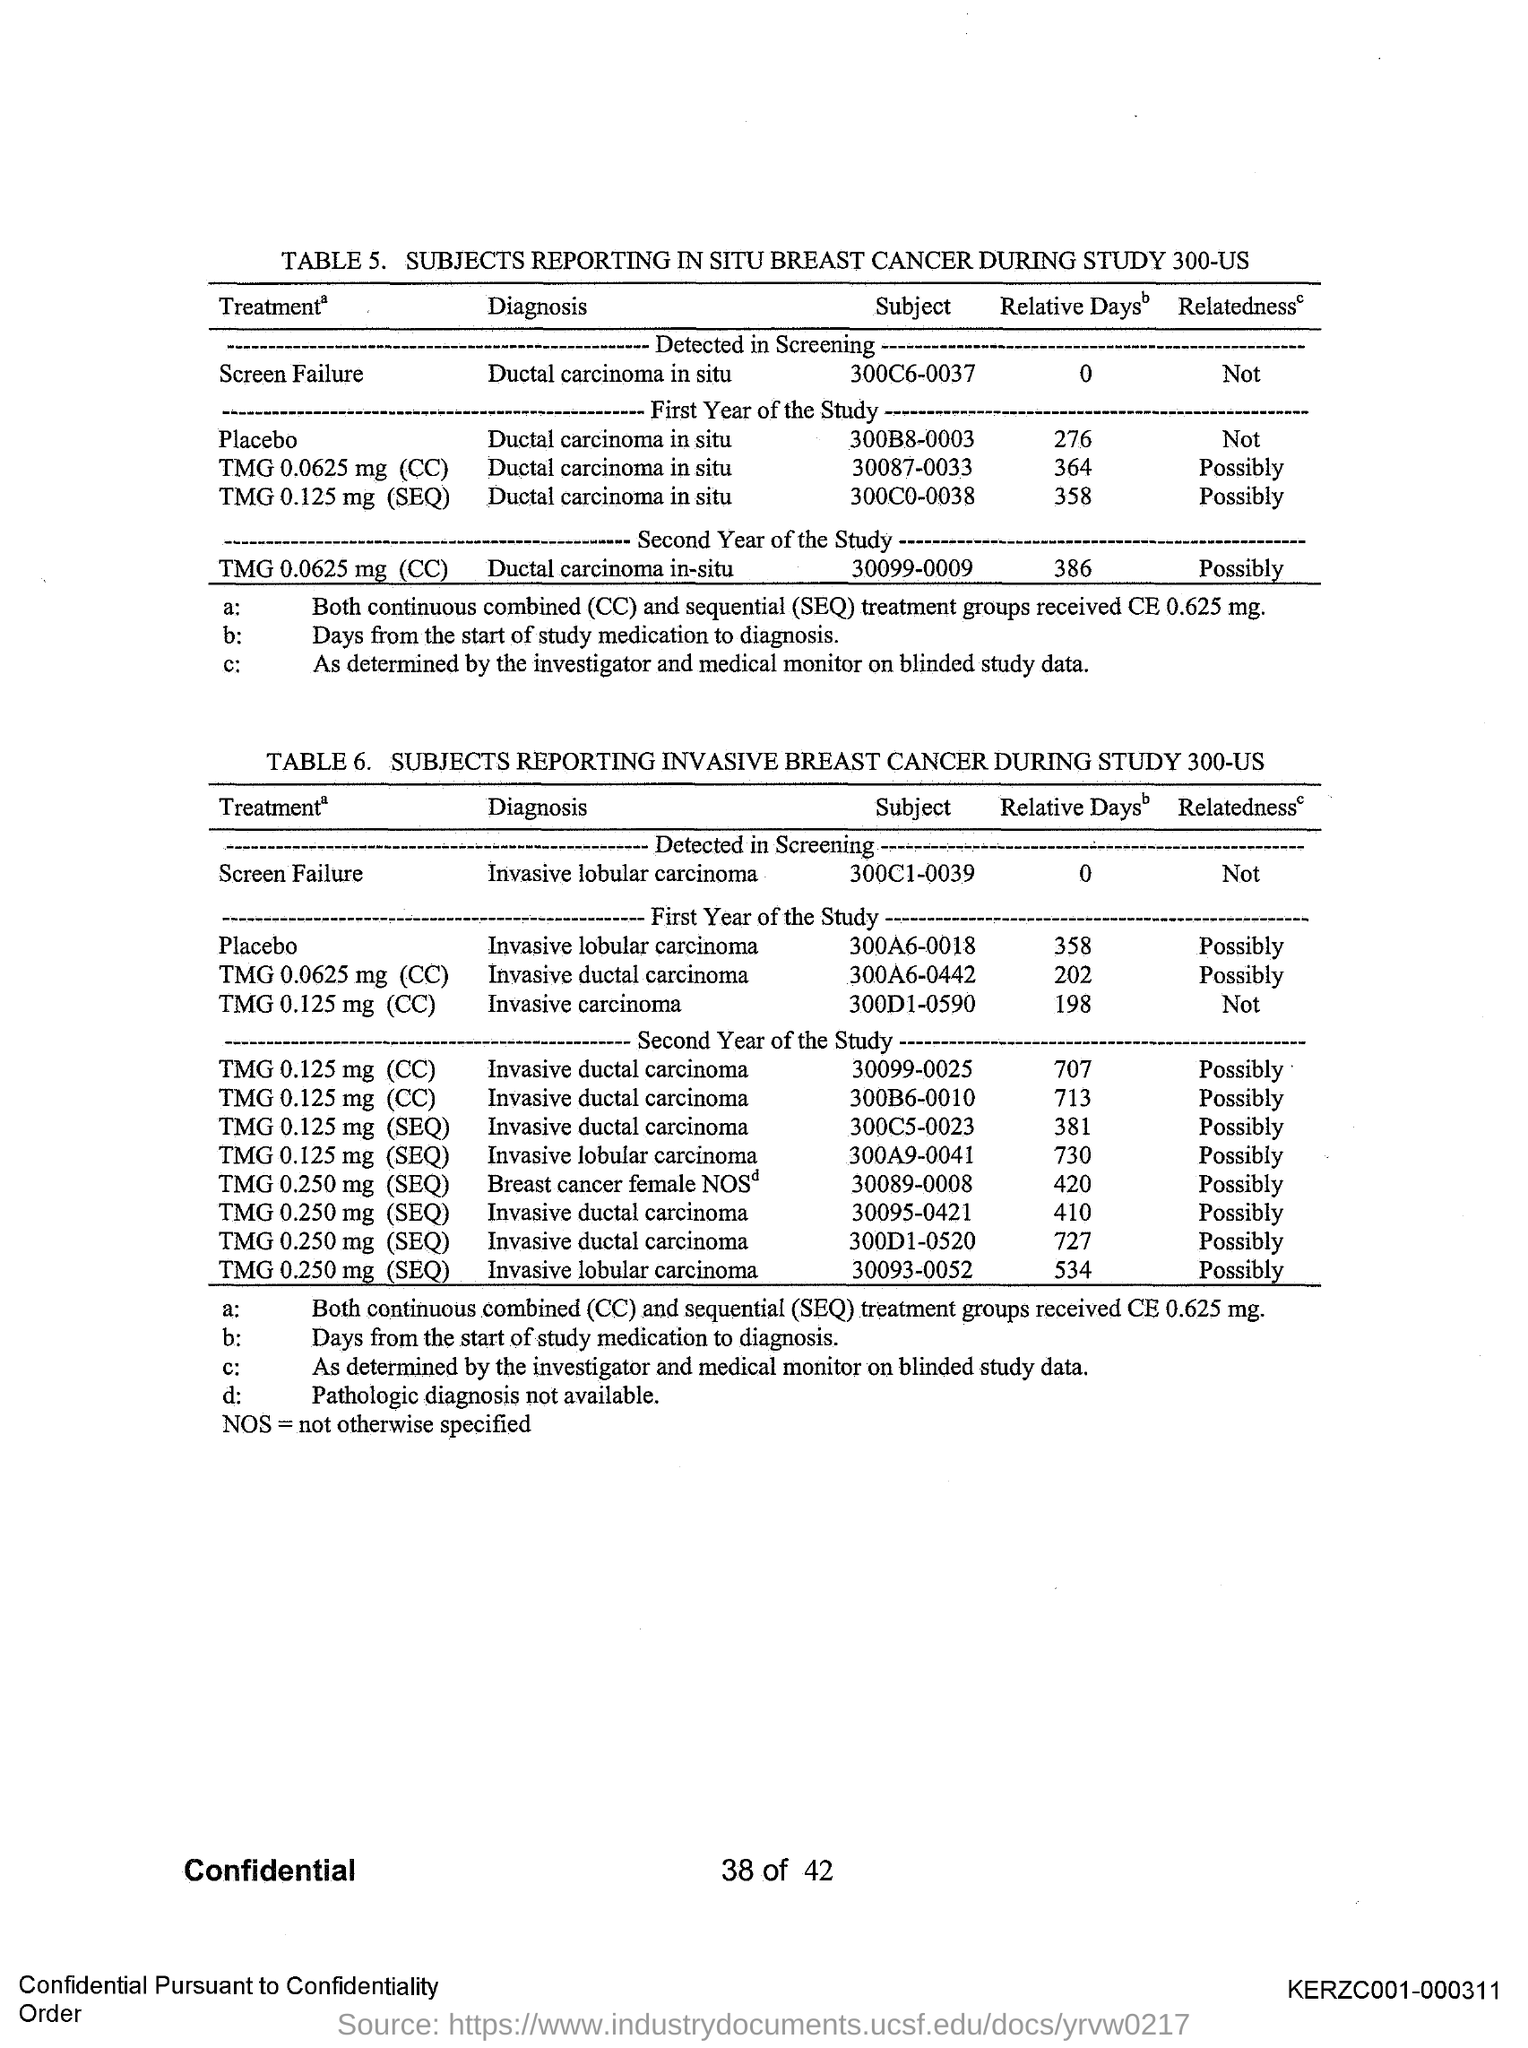What is the Page Number?
Your response must be concise. 38 of 42. What is the Document Number?
Provide a succinct answer. KERZC001-000311. 